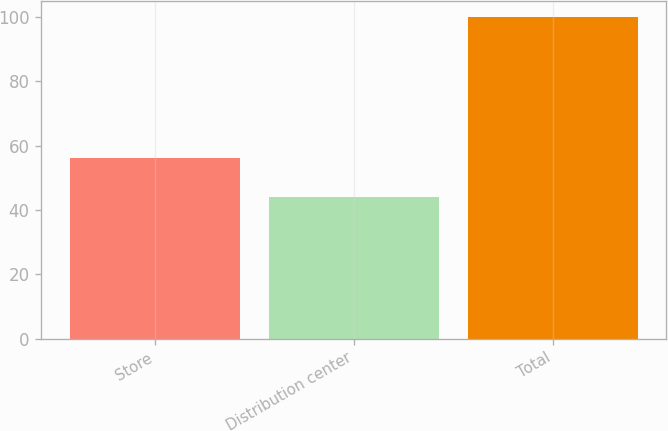<chart> <loc_0><loc_0><loc_500><loc_500><bar_chart><fcel>Store<fcel>Distribution center<fcel>Total<nl><fcel>56<fcel>44<fcel>100<nl></chart> 